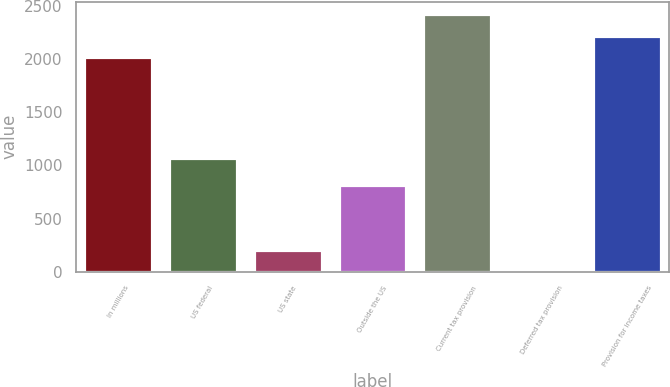Convert chart to OTSL. <chart><loc_0><loc_0><loc_500><loc_500><bar_chart><fcel>In millions<fcel>US federal<fcel>US state<fcel>Outside the US<fcel>Current tax provision<fcel>Deferred tax provision<fcel>Provision for income taxes<nl><fcel>2015<fcel>1072.3<fcel>204.04<fcel>816<fcel>2420.28<fcel>1.4<fcel>2217.64<nl></chart> 